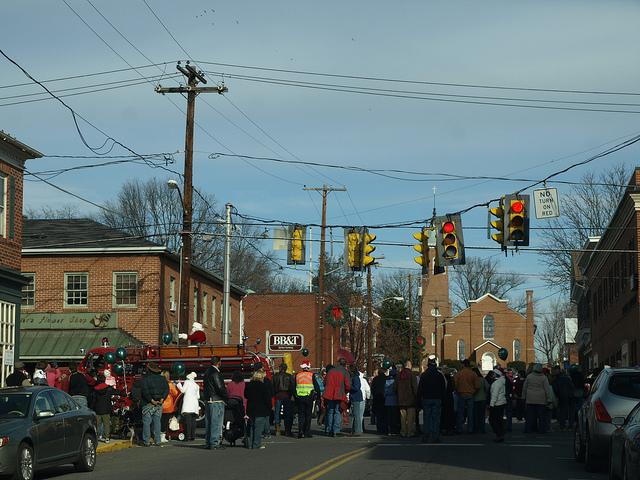Why are people in the middle of the street?

Choices:
A) parade passing
B) marathon
C) mass protest
D) fire sale parade passing 